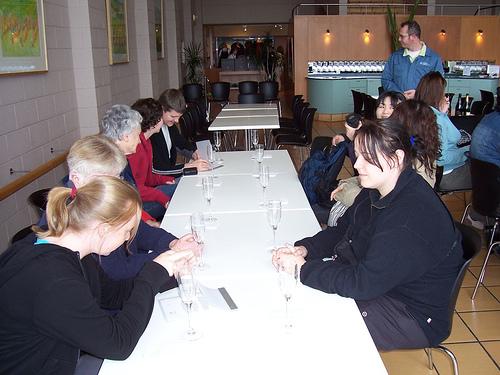Does everyone have cups?
Concise answer only. Yes. Is there anyone with a blue shirt?
Short answer required. Yes. Is this in a restaurant?
Answer briefly. Yes. 